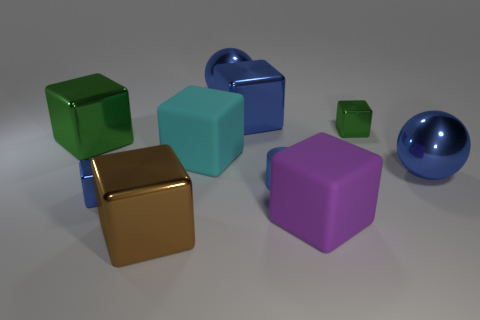Is the size of the blue cube that is right of the brown shiny cube the same as the brown shiny cube?
Your answer should be very brief. Yes. How many matte objects are small green blocks or big things?
Keep it short and to the point. 2. The block that is both in front of the large green shiny block and on the right side of the small blue cylinder is made of what material?
Offer a very short reply. Rubber. Are the cylinder and the small blue cube made of the same material?
Your answer should be very brief. Yes. There is a blue thing that is both left of the large blue shiny cube and behind the small green block; what size is it?
Provide a short and direct response. Large. The large green metallic thing is what shape?
Your answer should be compact. Cube. How many objects are either small cyan metallic things or purple matte objects right of the small blue metal cube?
Offer a terse response. 1. There is a tiny shiny cube that is in front of the big green block; is it the same color as the cylinder?
Ensure brevity in your answer.  Yes. What is the color of the object that is both behind the large purple matte cube and in front of the tiny blue shiny cylinder?
Your answer should be compact. Blue. There is a big cube that is on the left side of the big brown metallic object; what material is it?
Your answer should be compact. Metal. 